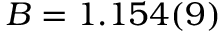Convert formula to latex. <formula><loc_0><loc_0><loc_500><loc_500>B = 1 . 1 5 4 ( 9 )</formula> 